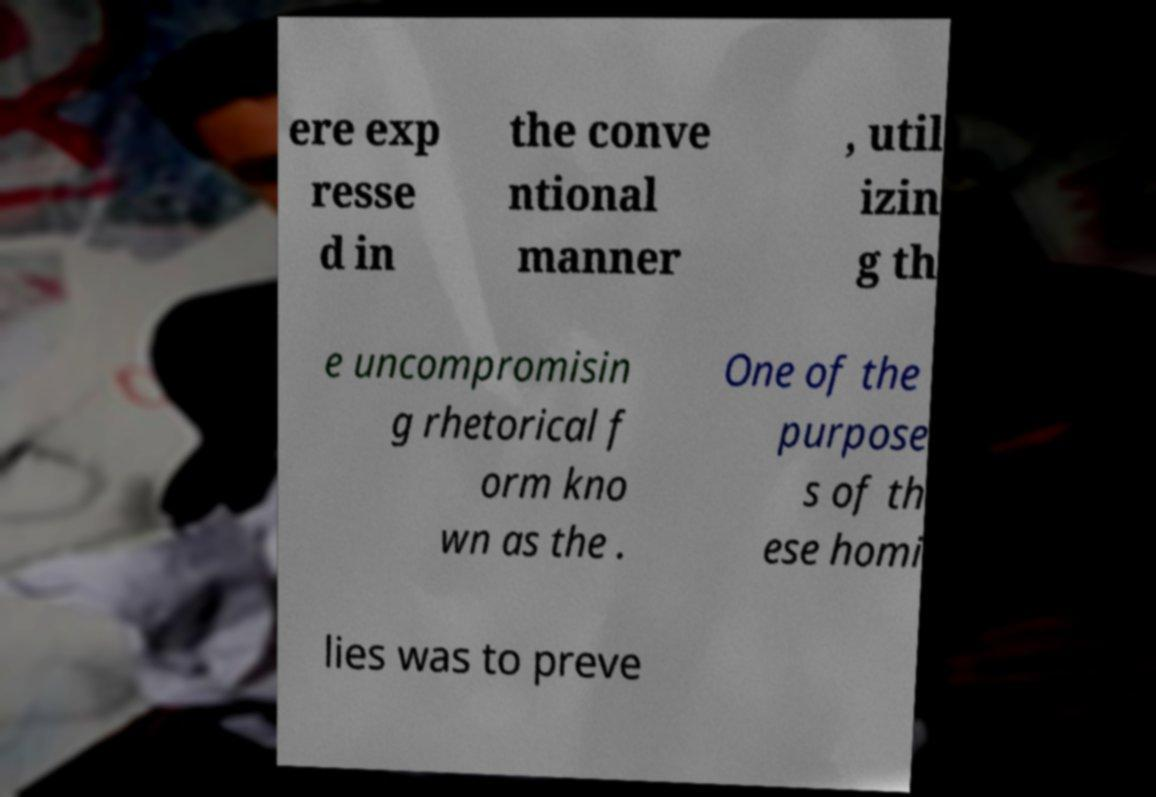Can you accurately transcribe the text from the provided image for me? ere exp resse d in the conve ntional manner , util izin g th e uncompromisin g rhetorical f orm kno wn as the . One of the purpose s of th ese homi lies was to preve 